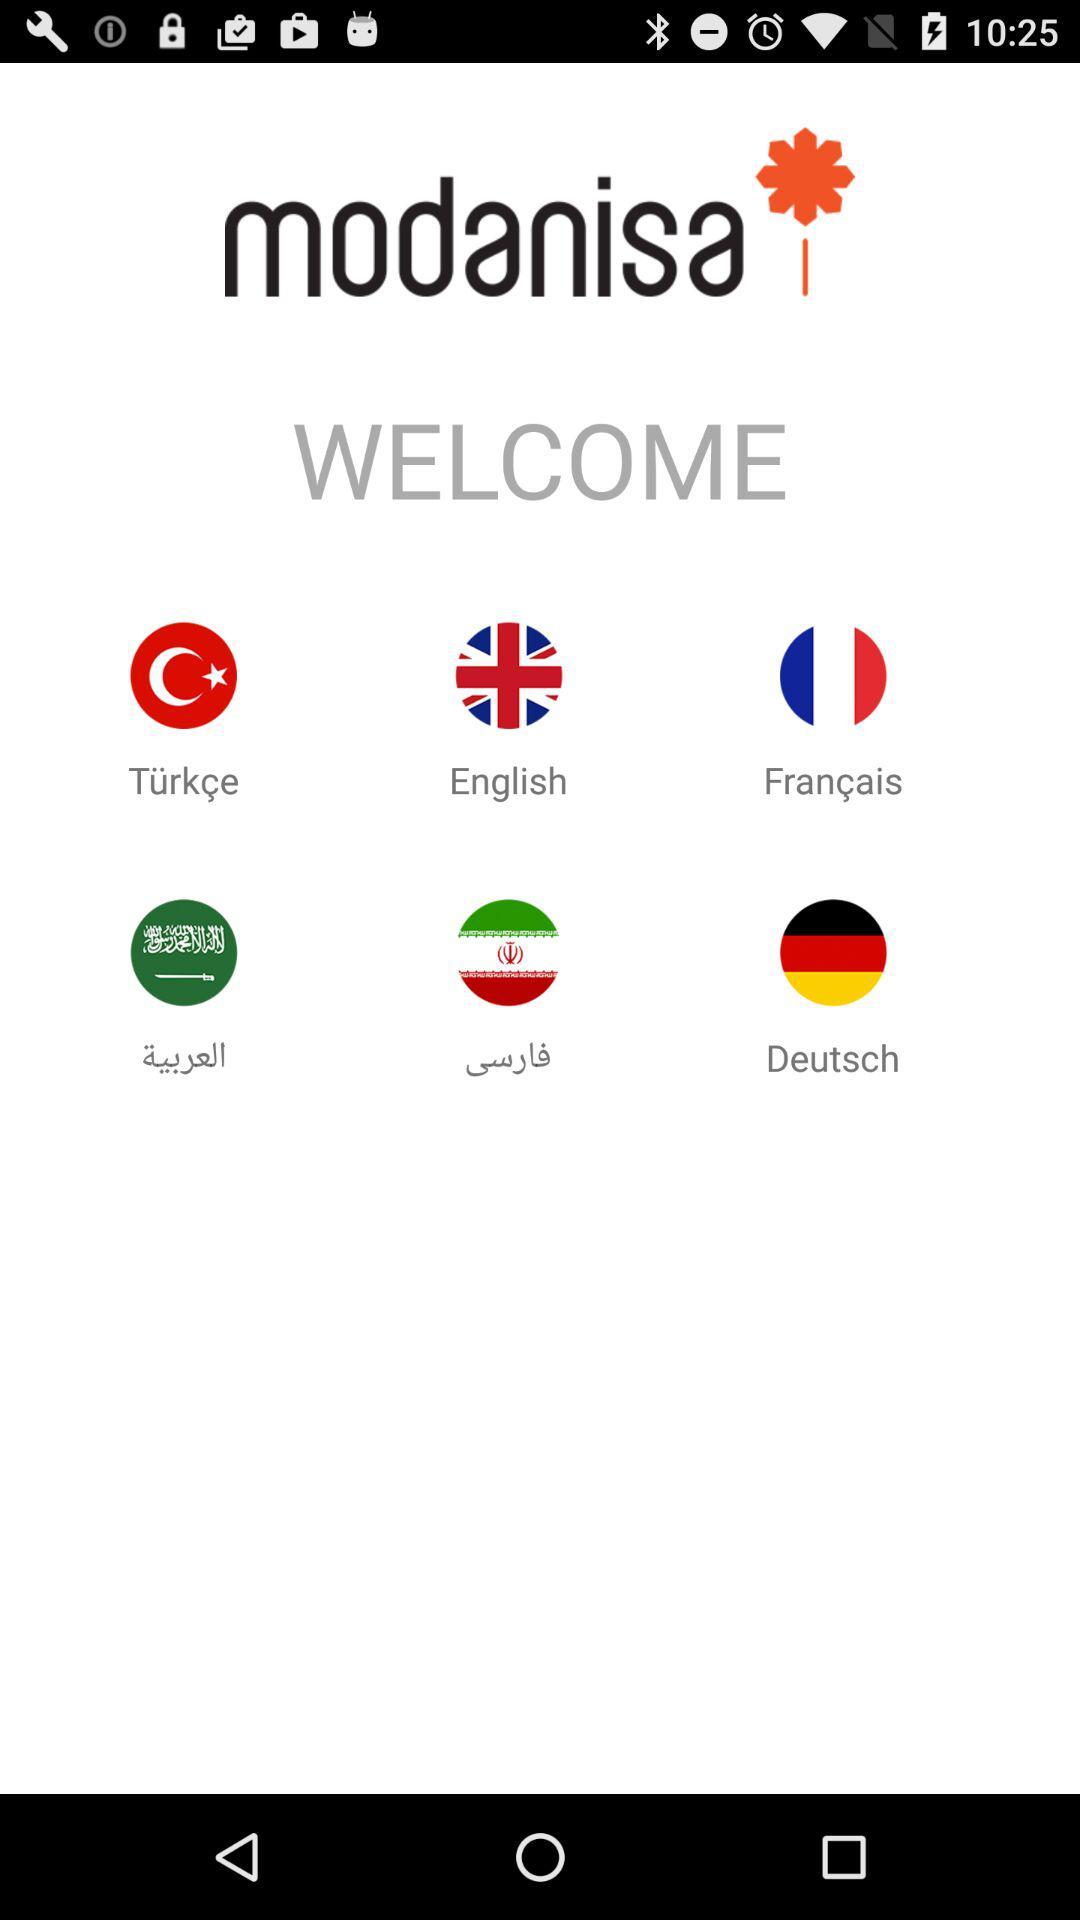What are the options available?
When the provided information is insufficient, respond with <no answer>. <no answer> 